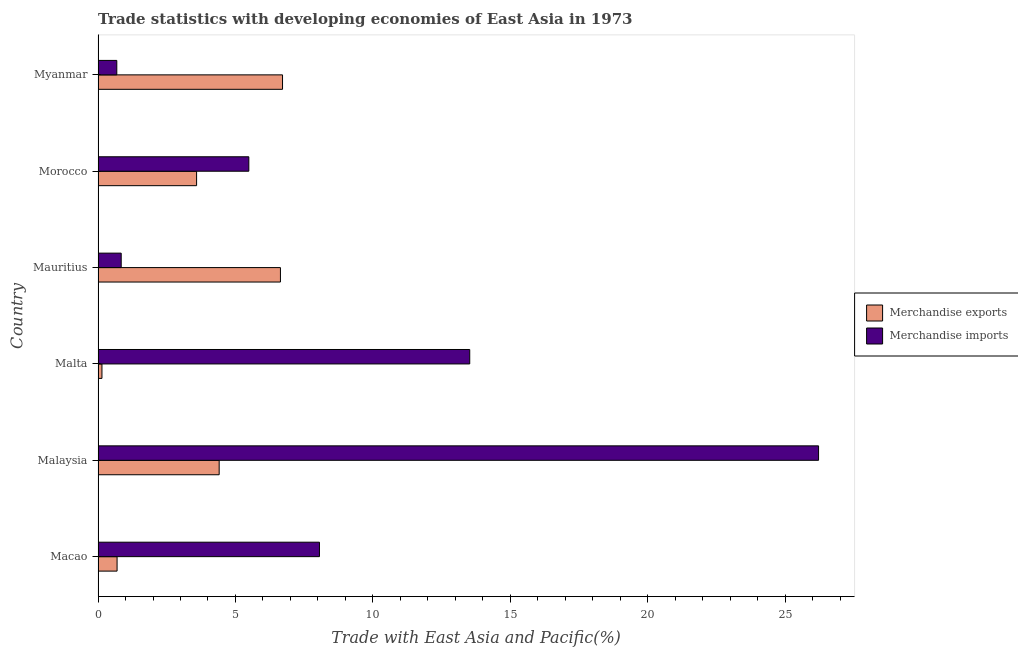How many different coloured bars are there?
Keep it short and to the point. 2. What is the label of the 3rd group of bars from the top?
Provide a short and direct response. Mauritius. What is the merchandise imports in Malaysia?
Give a very brief answer. 26.22. Across all countries, what is the maximum merchandise exports?
Give a very brief answer. 6.71. Across all countries, what is the minimum merchandise imports?
Provide a succinct answer. 0.68. In which country was the merchandise exports maximum?
Offer a terse response. Myanmar. In which country was the merchandise exports minimum?
Provide a succinct answer. Malta. What is the total merchandise exports in the graph?
Your answer should be compact. 22.18. What is the difference between the merchandise imports in Malaysia and that in Myanmar?
Ensure brevity in your answer.  25.53. What is the difference between the merchandise imports in Malta and the merchandise exports in Morocco?
Keep it short and to the point. 9.94. What is the average merchandise imports per country?
Offer a terse response. 9.13. What is the difference between the merchandise exports and merchandise imports in Malta?
Provide a short and direct response. -13.38. What is the ratio of the merchandise exports in Morocco to that in Myanmar?
Keep it short and to the point. 0.53. What is the difference between the highest and the second highest merchandise exports?
Offer a terse response. 0.08. What is the difference between the highest and the lowest merchandise exports?
Provide a short and direct response. 6.57. Is the sum of the merchandise exports in Malta and Mauritius greater than the maximum merchandise imports across all countries?
Provide a succinct answer. No. What does the 2nd bar from the bottom in Macao represents?
Make the answer very short. Merchandise imports. Does the graph contain any zero values?
Keep it short and to the point. No. Where does the legend appear in the graph?
Provide a succinct answer. Center right. What is the title of the graph?
Give a very brief answer. Trade statistics with developing economies of East Asia in 1973. Does "constant 2005 US$" appear as one of the legend labels in the graph?
Ensure brevity in your answer.  No. What is the label or title of the X-axis?
Offer a terse response. Trade with East Asia and Pacific(%). What is the label or title of the Y-axis?
Keep it short and to the point. Country. What is the Trade with East Asia and Pacific(%) in Merchandise exports in Macao?
Your response must be concise. 0.69. What is the Trade with East Asia and Pacific(%) in Merchandise imports in Macao?
Offer a very short reply. 8.06. What is the Trade with East Asia and Pacific(%) of Merchandise exports in Malaysia?
Provide a short and direct response. 4.41. What is the Trade with East Asia and Pacific(%) of Merchandise imports in Malaysia?
Ensure brevity in your answer.  26.22. What is the Trade with East Asia and Pacific(%) in Merchandise exports in Malta?
Offer a terse response. 0.14. What is the Trade with East Asia and Pacific(%) of Merchandise imports in Malta?
Ensure brevity in your answer.  13.52. What is the Trade with East Asia and Pacific(%) of Merchandise exports in Mauritius?
Provide a succinct answer. 6.64. What is the Trade with East Asia and Pacific(%) of Merchandise imports in Mauritius?
Provide a succinct answer. 0.84. What is the Trade with East Asia and Pacific(%) of Merchandise exports in Morocco?
Keep it short and to the point. 3.59. What is the Trade with East Asia and Pacific(%) in Merchandise imports in Morocco?
Ensure brevity in your answer.  5.49. What is the Trade with East Asia and Pacific(%) in Merchandise exports in Myanmar?
Ensure brevity in your answer.  6.71. What is the Trade with East Asia and Pacific(%) of Merchandise imports in Myanmar?
Provide a short and direct response. 0.68. Across all countries, what is the maximum Trade with East Asia and Pacific(%) in Merchandise exports?
Your answer should be very brief. 6.71. Across all countries, what is the maximum Trade with East Asia and Pacific(%) in Merchandise imports?
Your response must be concise. 26.22. Across all countries, what is the minimum Trade with East Asia and Pacific(%) of Merchandise exports?
Ensure brevity in your answer.  0.14. Across all countries, what is the minimum Trade with East Asia and Pacific(%) of Merchandise imports?
Your response must be concise. 0.68. What is the total Trade with East Asia and Pacific(%) of Merchandise exports in the graph?
Offer a very short reply. 22.18. What is the total Trade with East Asia and Pacific(%) in Merchandise imports in the graph?
Make the answer very short. 54.81. What is the difference between the Trade with East Asia and Pacific(%) of Merchandise exports in Macao and that in Malaysia?
Offer a very short reply. -3.71. What is the difference between the Trade with East Asia and Pacific(%) in Merchandise imports in Macao and that in Malaysia?
Offer a terse response. -18.16. What is the difference between the Trade with East Asia and Pacific(%) in Merchandise exports in Macao and that in Malta?
Give a very brief answer. 0.55. What is the difference between the Trade with East Asia and Pacific(%) of Merchandise imports in Macao and that in Malta?
Offer a very short reply. -5.47. What is the difference between the Trade with East Asia and Pacific(%) in Merchandise exports in Macao and that in Mauritius?
Offer a terse response. -5.94. What is the difference between the Trade with East Asia and Pacific(%) in Merchandise imports in Macao and that in Mauritius?
Offer a terse response. 7.21. What is the difference between the Trade with East Asia and Pacific(%) in Merchandise exports in Macao and that in Morocco?
Your answer should be very brief. -2.89. What is the difference between the Trade with East Asia and Pacific(%) of Merchandise imports in Macao and that in Morocco?
Your answer should be very brief. 2.57. What is the difference between the Trade with East Asia and Pacific(%) of Merchandise exports in Macao and that in Myanmar?
Your answer should be compact. -6.02. What is the difference between the Trade with East Asia and Pacific(%) in Merchandise imports in Macao and that in Myanmar?
Keep it short and to the point. 7.37. What is the difference between the Trade with East Asia and Pacific(%) of Merchandise exports in Malaysia and that in Malta?
Your response must be concise. 4.26. What is the difference between the Trade with East Asia and Pacific(%) of Merchandise imports in Malaysia and that in Malta?
Provide a short and direct response. 12.69. What is the difference between the Trade with East Asia and Pacific(%) of Merchandise exports in Malaysia and that in Mauritius?
Provide a succinct answer. -2.23. What is the difference between the Trade with East Asia and Pacific(%) in Merchandise imports in Malaysia and that in Mauritius?
Your answer should be compact. 25.37. What is the difference between the Trade with East Asia and Pacific(%) in Merchandise exports in Malaysia and that in Morocco?
Your answer should be very brief. 0.82. What is the difference between the Trade with East Asia and Pacific(%) of Merchandise imports in Malaysia and that in Morocco?
Ensure brevity in your answer.  20.73. What is the difference between the Trade with East Asia and Pacific(%) of Merchandise exports in Malaysia and that in Myanmar?
Keep it short and to the point. -2.31. What is the difference between the Trade with East Asia and Pacific(%) in Merchandise imports in Malaysia and that in Myanmar?
Your answer should be compact. 25.53. What is the difference between the Trade with East Asia and Pacific(%) of Merchandise exports in Malta and that in Mauritius?
Your answer should be very brief. -6.49. What is the difference between the Trade with East Asia and Pacific(%) in Merchandise imports in Malta and that in Mauritius?
Your response must be concise. 12.68. What is the difference between the Trade with East Asia and Pacific(%) in Merchandise exports in Malta and that in Morocco?
Offer a terse response. -3.44. What is the difference between the Trade with East Asia and Pacific(%) in Merchandise imports in Malta and that in Morocco?
Keep it short and to the point. 8.04. What is the difference between the Trade with East Asia and Pacific(%) of Merchandise exports in Malta and that in Myanmar?
Give a very brief answer. -6.57. What is the difference between the Trade with East Asia and Pacific(%) in Merchandise imports in Malta and that in Myanmar?
Offer a terse response. 12.84. What is the difference between the Trade with East Asia and Pacific(%) of Merchandise exports in Mauritius and that in Morocco?
Offer a very short reply. 3.05. What is the difference between the Trade with East Asia and Pacific(%) in Merchandise imports in Mauritius and that in Morocco?
Your response must be concise. -4.64. What is the difference between the Trade with East Asia and Pacific(%) in Merchandise exports in Mauritius and that in Myanmar?
Give a very brief answer. -0.08. What is the difference between the Trade with East Asia and Pacific(%) of Merchandise imports in Mauritius and that in Myanmar?
Your answer should be compact. 0.16. What is the difference between the Trade with East Asia and Pacific(%) in Merchandise exports in Morocco and that in Myanmar?
Your response must be concise. -3.13. What is the difference between the Trade with East Asia and Pacific(%) in Merchandise imports in Morocco and that in Myanmar?
Your answer should be very brief. 4.8. What is the difference between the Trade with East Asia and Pacific(%) in Merchandise exports in Macao and the Trade with East Asia and Pacific(%) in Merchandise imports in Malaysia?
Offer a very short reply. -25.52. What is the difference between the Trade with East Asia and Pacific(%) of Merchandise exports in Macao and the Trade with East Asia and Pacific(%) of Merchandise imports in Malta?
Offer a terse response. -12.83. What is the difference between the Trade with East Asia and Pacific(%) in Merchandise exports in Macao and the Trade with East Asia and Pacific(%) in Merchandise imports in Mauritius?
Give a very brief answer. -0.15. What is the difference between the Trade with East Asia and Pacific(%) of Merchandise exports in Macao and the Trade with East Asia and Pacific(%) of Merchandise imports in Morocco?
Your answer should be compact. -4.79. What is the difference between the Trade with East Asia and Pacific(%) of Merchandise exports in Malaysia and the Trade with East Asia and Pacific(%) of Merchandise imports in Malta?
Make the answer very short. -9.12. What is the difference between the Trade with East Asia and Pacific(%) in Merchandise exports in Malaysia and the Trade with East Asia and Pacific(%) in Merchandise imports in Mauritius?
Offer a terse response. 3.56. What is the difference between the Trade with East Asia and Pacific(%) of Merchandise exports in Malaysia and the Trade with East Asia and Pacific(%) of Merchandise imports in Morocco?
Provide a short and direct response. -1.08. What is the difference between the Trade with East Asia and Pacific(%) in Merchandise exports in Malaysia and the Trade with East Asia and Pacific(%) in Merchandise imports in Myanmar?
Offer a terse response. 3.72. What is the difference between the Trade with East Asia and Pacific(%) of Merchandise exports in Malta and the Trade with East Asia and Pacific(%) of Merchandise imports in Mauritius?
Keep it short and to the point. -0.7. What is the difference between the Trade with East Asia and Pacific(%) of Merchandise exports in Malta and the Trade with East Asia and Pacific(%) of Merchandise imports in Morocco?
Give a very brief answer. -5.34. What is the difference between the Trade with East Asia and Pacific(%) of Merchandise exports in Malta and the Trade with East Asia and Pacific(%) of Merchandise imports in Myanmar?
Offer a very short reply. -0.54. What is the difference between the Trade with East Asia and Pacific(%) of Merchandise exports in Mauritius and the Trade with East Asia and Pacific(%) of Merchandise imports in Morocco?
Your response must be concise. 1.15. What is the difference between the Trade with East Asia and Pacific(%) in Merchandise exports in Mauritius and the Trade with East Asia and Pacific(%) in Merchandise imports in Myanmar?
Ensure brevity in your answer.  5.95. What is the difference between the Trade with East Asia and Pacific(%) in Merchandise exports in Morocco and the Trade with East Asia and Pacific(%) in Merchandise imports in Myanmar?
Your answer should be very brief. 2.9. What is the average Trade with East Asia and Pacific(%) in Merchandise exports per country?
Give a very brief answer. 3.7. What is the average Trade with East Asia and Pacific(%) in Merchandise imports per country?
Make the answer very short. 9.13. What is the difference between the Trade with East Asia and Pacific(%) in Merchandise exports and Trade with East Asia and Pacific(%) in Merchandise imports in Macao?
Your answer should be compact. -7.36. What is the difference between the Trade with East Asia and Pacific(%) of Merchandise exports and Trade with East Asia and Pacific(%) of Merchandise imports in Malaysia?
Your answer should be very brief. -21.81. What is the difference between the Trade with East Asia and Pacific(%) in Merchandise exports and Trade with East Asia and Pacific(%) in Merchandise imports in Malta?
Make the answer very short. -13.38. What is the difference between the Trade with East Asia and Pacific(%) of Merchandise exports and Trade with East Asia and Pacific(%) of Merchandise imports in Mauritius?
Your response must be concise. 5.79. What is the difference between the Trade with East Asia and Pacific(%) of Merchandise exports and Trade with East Asia and Pacific(%) of Merchandise imports in Morocco?
Ensure brevity in your answer.  -1.9. What is the difference between the Trade with East Asia and Pacific(%) in Merchandise exports and Trade with East Asia and Pacific(%) in Merchandise imports in Myanmar?
Offer a very short reply. 6.03. What is the ratio of the Trade with East Asia and Pacific(%) in Merchandise exports in Macao to that in Malaysia?
Your response must be concise. 0.16. What is the ratio of the Trade with East Asia and Pacific(%) of Merchandise imports in Macao to that in Malaysia?
Your response must be concise. 0.31. What is the ratio of the Trade with East Asia and Pacific(%) of Merchandise exports in Macao to that in Malta?
Keep it short and to the point. 4.87. What is the ratio of the Trade with East Asia and Pacific(%) of Merchandise imports in Macao to that in Malta?
Keep it short and to the point. 0.6. What is the ratio of the Trade with East Asia and Pacific(%) of Merchandise exports in Macao to that in Mauritius?
Make the answer very short. 0.1. What is the ratio of the Trade with East Asia and Pacific(%) in Merchandise imports in Macao to that in Mauritius?
Ensure brevity in your answer.  9.56. What is the ratio of the Trade with East Asia and Pacific(%) in Merchandise exports in Macao to that in Morocco?
Give a very brief answer. 0.19. What is the ratio of the Trade with East Asia and Pacific(%) in Merchandise imports in Macao to that in Morocco?
Your response must be concise. 1.47. What is the ratio of the Trade with East Asia and Pacific(%) of Merchandise exports in Macao to that in Myanmar?
Your answer should be compact. 0.1. What is the ratio of the Trade with East Asia and Pacific(%) in Merchandise imports in Macao to that in Myanmar?
Provide a short and direct response. 11.81. What is the ratio of the Trade with East Asia and Pacific(%) in Merchandise exports in Malaysia to that in Malta?
Your answer should be compact. 31. What is the ratio of the Trade with East Asia and Pacific(%) of Merchandise imports in Malaysia to that in Malta?
Your response must be concise. 1.94. What is the ratio of the Trade with East Asia and Pacific(%) in Merchandise exports in Malaysia to that in Mauritius?
Offer a terse response. 0.66. What is the ratio of the Trade with East Asia and Pacific(%) of Merchandise imports in Malaysia to that in Mauritius?
Give a very brief answer. 31.11. What is the ratio of the Trade with East Asia and Pacific(%) in Merchandise exports in Malaysia to that in Morocco?
Keep it short and to the point. 1.23. What is the ratio of the Trade with East Asia and Pacific(%) of Merchandise imports in Malaysia to that in Morocco?
Your answer should be very brief. 4.78. What is the ratio of the Trade with East Asia and Pacific(%) of Merchandise exports in Malaysia to that in Myanmar?
Your answer should be very brief. 0.66. What is the ratio of the Trade with East Asia and Pacific(%) in Merchandise imports in Malaysia to that in Myanmar?
Offer a very short reply. 38.43. What is the ratio of the Trade with East Asia and Pacific(%) of Merchandise exports in Malta to that in Mauritius?
Offer a very short reply. 0.02. What is the ratio of the Trade with East Asia and Pacific(%) in Merchandise imports in Malta to that in Mauritius?
Make the answer very short. 16.05. What is the ratio of the Trade with East Asia and Pacific(%) of Merchandise exports in Malta to that in Morocco?
Your response must be concise. 0.04. What is the ratio of the Trade with East Asia and Pacific(%) of Merchandise imports in Malta to that in Morocco?
Your response must be concise. 2.46. What is the ratio of the Trade with East Asia and Pacific(%) in Merchandise exports in Malta to that in Myanmar?
Offer a very short reply. 0.02. What is the ratio of the Trade with East Asia and Pacific(%) in Merchandise imports in Malta to that in Myanmar?
Offer a very short reply. 19.83. What is the ratio of the Trade with East Asia and Pacific(%) of Merchandise exports in Mauritius to that in Morocco?
Your answer should be very brief. 1.85. What is the ratio of the Trade with East Asia and Pacific(%) of Merchandise imports in Mauritius to that in Morocco?
Your response must be concise. 0.15. What is the ratio of the Trade with East Asia and Pacific(%) in Merchandise exports in Mauritius to that in Myanmar?
Your response must be concise. 0.99. What is the ratio of the Trade with East Asia and Pacific(%) in Merchandise imports in Mauritius to that in Myanmar?
Offer a very short reply. 1.24. What is the ratio of the Trade with East Asia and Pacific(%) in Merchandise exports in Morocco to that in Myanmar?
Keep it short and to the point. 0.53. What is the ratio of the Trade with East Asia and Pacific(%) in Merchandise imports in Morocco to that in Myanmar?
Offer a terse response. 8.04. What is the difference between the highest and the second highest Trade with East Asia and Pacific(%) of Merchandise exports?
Offer a very short reply. 0.08. What is the difference between the highest and the second highest Trade with East Asia and Pacific(%) in Merchandise imports?
Your answer should be compact. 12.69. What is the difference between the highest and the lowest Trade with East Asia and Pacific(%) of Merchandise exports?
Provide a short and direct response. 6.57. What is the difference between the highest and the lowest Trade with East Asia and Pacific(%) of Merchandise imports?
Ensure brevity in your answer.  25.53. 